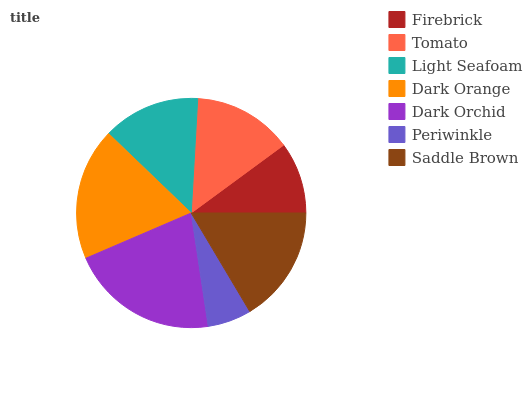Is Periwinkle the minimum?
Answer yes or no. Yes. Is Dark Orchid the maximum?
Answer yes or no. Yes. Is Tomato the minimum?
Answer yes or no. No. Is Tomato the maximum?
Answer yes or no. No. Is Tomato greater than Firebrick?
Answer yes or no. Yes. Is Firebrick less than Tomato?
Answer yes or no. Yes. Is Firebrick greater than Tomato?
Answer yes or no. No. Is Tomato less than Firebrick?
Answer yes or no. No. Is Tomato the high median?
Answer yes or no. Yes. Is Tomato the low median?
Answer yes or no. Yes. Is Saddle Brown the high median?
Answer yes or no. No. Is Saddle Brown the low median?
Answer yes or no. No. 